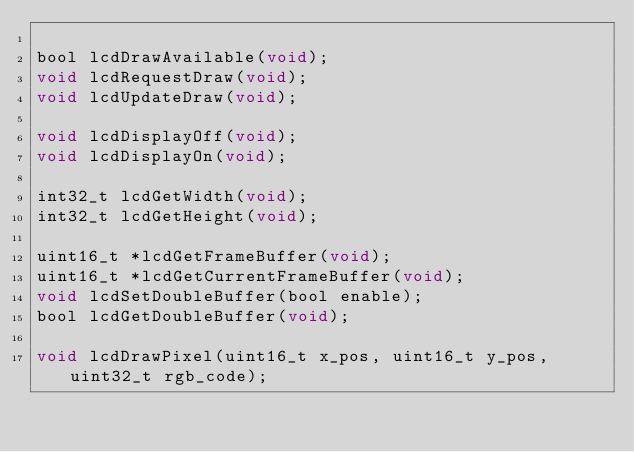Convert code to text. <code><loc_0><loc_0><loc_500><loc_500><_C_>
bool lcdDrawAvailable(void);
void lcdRequestDraw(void);
void lcdUpdateDraw(void);

void lcdDisplayOff(void);
void lcdDisplayOn(void);

int32_t lcdGetWidth(void);
int32_t lcdGetHeight(void);

uint16_t *lcdGetFrameBuffer(void);
uint16_t *lcdGetCurrentFrameBuffer(void);
void lcdSetDoubleBuffer(bool enable);
bool lcdGetDoubleBuffer(void);

void lcdDrawPixel(uint16_t x_pos, uint16_t y_pos, uint32_t rgb_code);</code> 